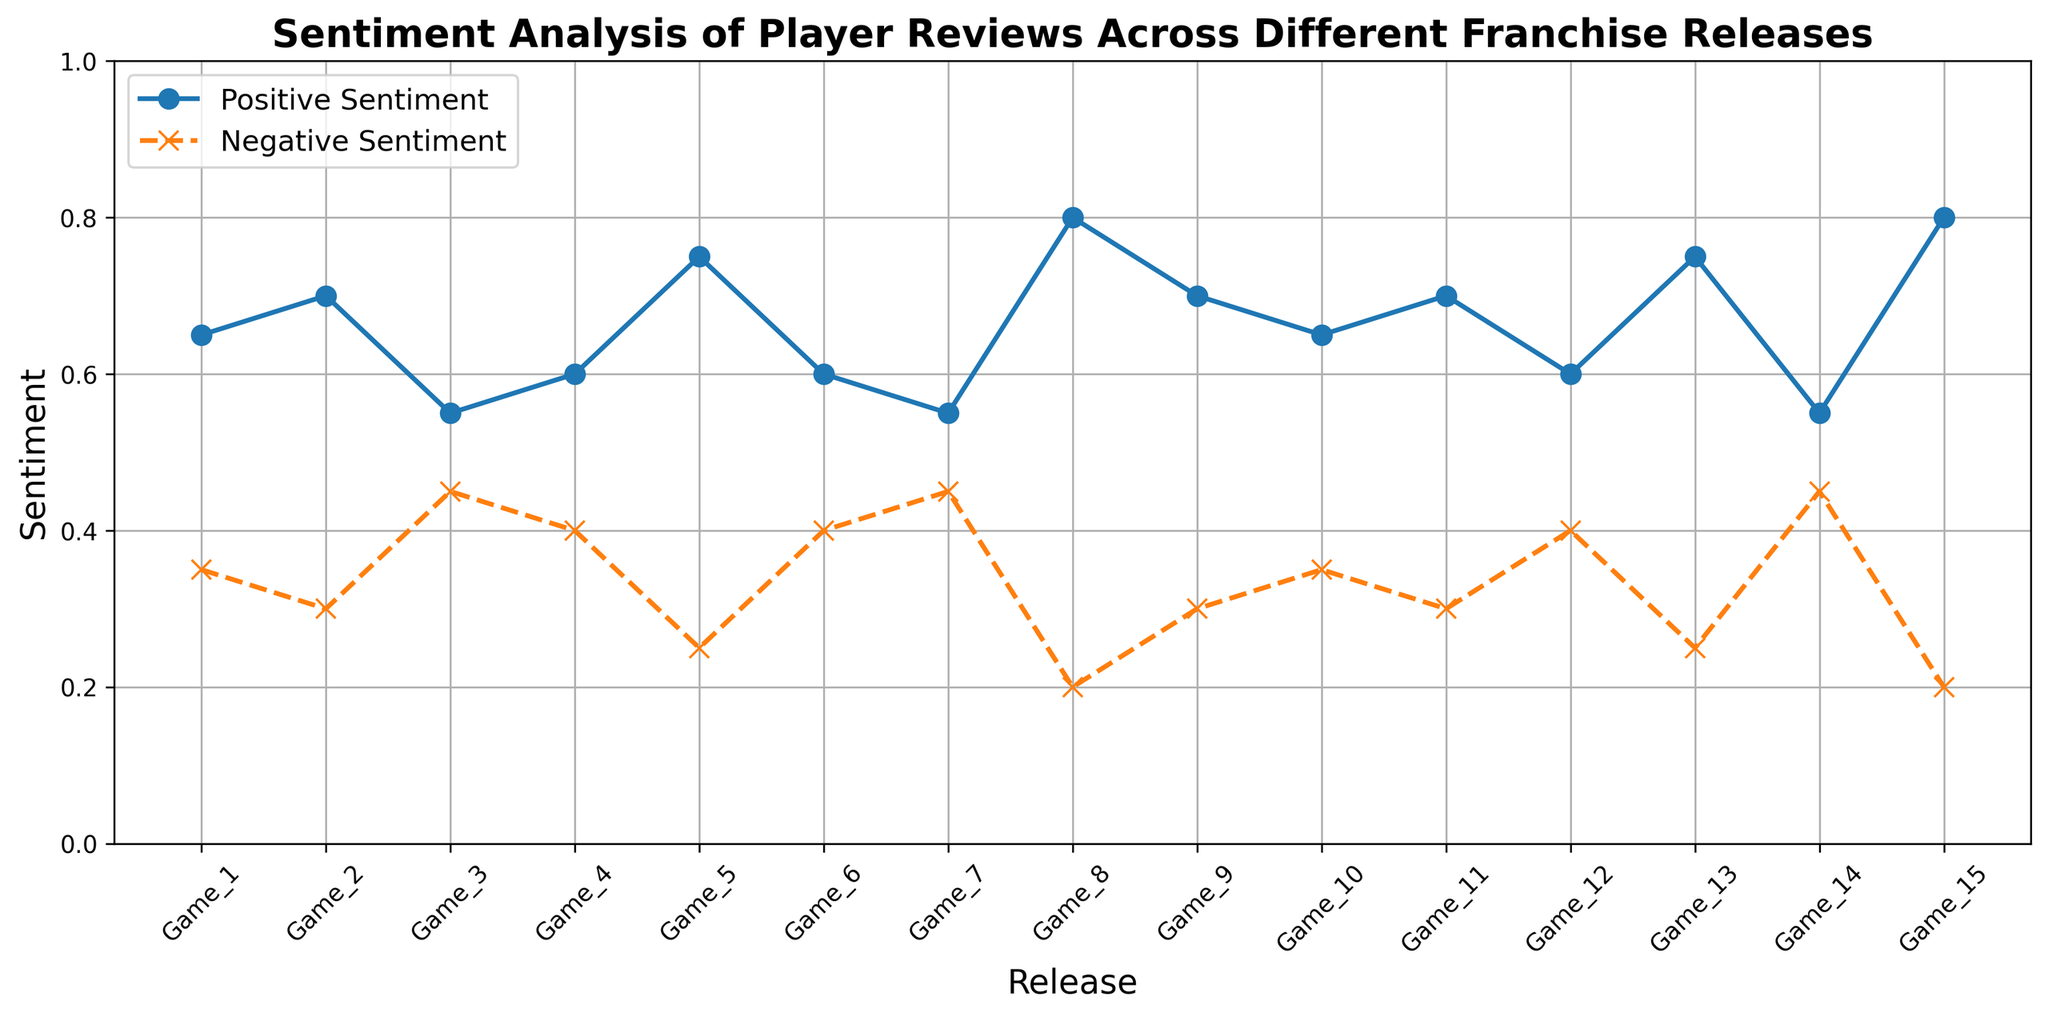Which release has the highest positive sentiment? The line representing positive sentiment peaks at "Game_8" and "Game_15". Both games have a positive sentiment value of 0.8, which is the highest.
Answer: Game_8 and Game_15 Which release has the highest negative sentiment? The line representing negative sentiment peaks at "Game_3", "Game_7", and "Game_14". All these games have a negative sentiment value of 0.45, which is the highest.
Answer: Game_3, Game_7, and Game_14 What is the trend of positive sentiment from "Game_1" to "Game_15"? The positive sentiment starts at 0.65 for "Game_1", increases to 0.8 in "Game_8" and "Game_15" with some fluctuations in between. Generally, there's an increasing trend with some dips.
Answer: Increasing with fluctuations Which release had an equal balance of positive and negative sentiment, and what was the proportion? No release shows an equal balance where positive sentiment equals negative sentiment.
Answer: None How many releases showed a higher positive sentiment than 0.7? Positive sentiment is higher than 0.7 for "Game_8", "Game_13", and "Game_15". So, there are 3 releases.
Answer: 3 In which releases is the positive sentiment exactly 0.6? The positive sentiment is exactly 0.6 for "Game_4", "Game_6", and "Game_12".
Answer: Game_4, Game_6, Game_12 What is the average positive sentiment across all releases? Sum up all positive sentiments (0.65+0.7+0.55+0.6+0.75+0.6+0.55+0.8+0.7+0.65+0.7+0.6+0.75+0.55+0.8) which equals 9.45. Dividing by the number of releases (15) gives the average, 9.45 / 15 = 0.63.
Answer: 0.63 Which release showed the most significant increase in positive sentiment compared to the previous release? The most significant jump in positive sentiment is found between "Game_14" (0.55) and "Game_15" (0.8), which is an increase of 0.25.
Answer: Game_14 to Game_15 